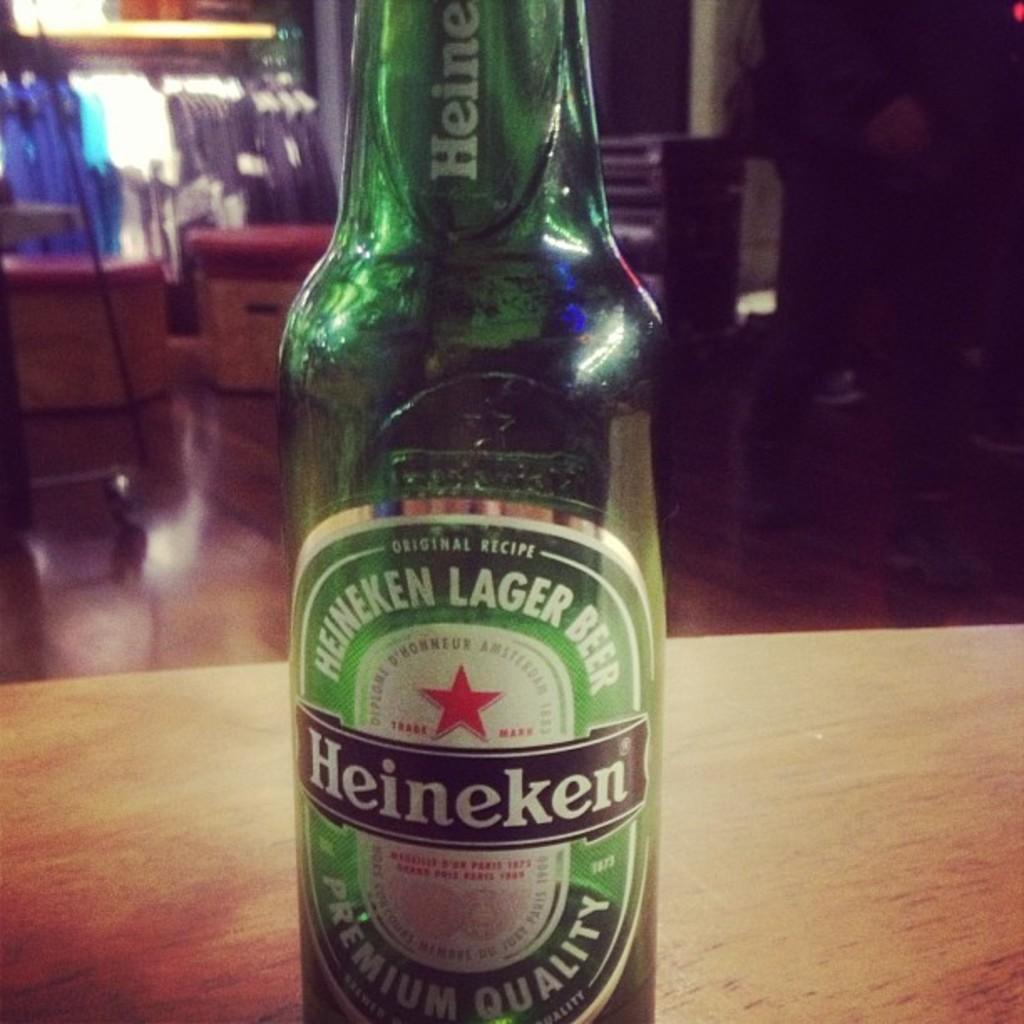What kind of beer is this?
Offer a terse response. Heineken. 